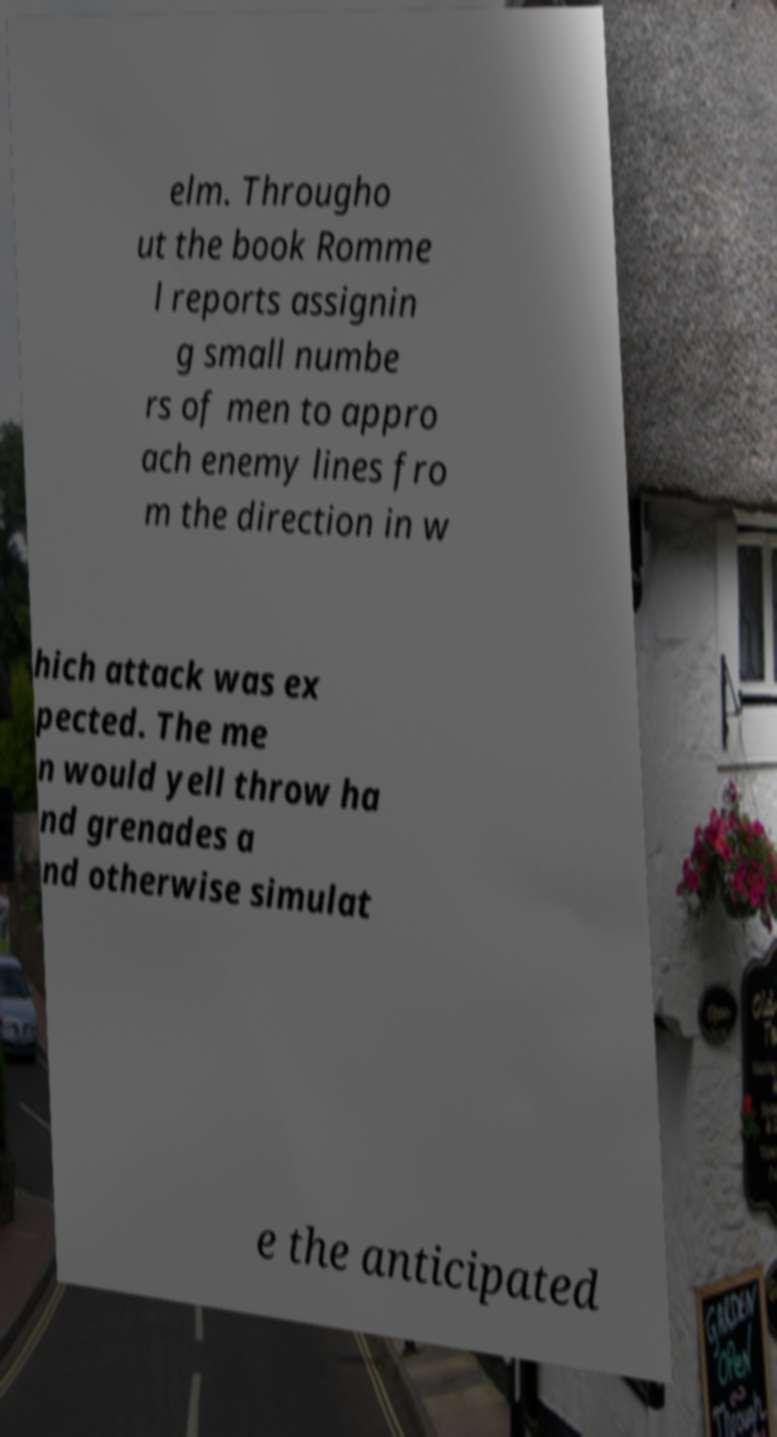Could you assist in decoding the text presented in this image and type it out clearly? elm. Througho ut the book Romme l reports assignin g small numbe rs of men to appro ach enemy lines fro m the direction in w hich attack was ex pected. The me n would yell throw ha nd grenades a nd otherwise simulat e the anticipated 